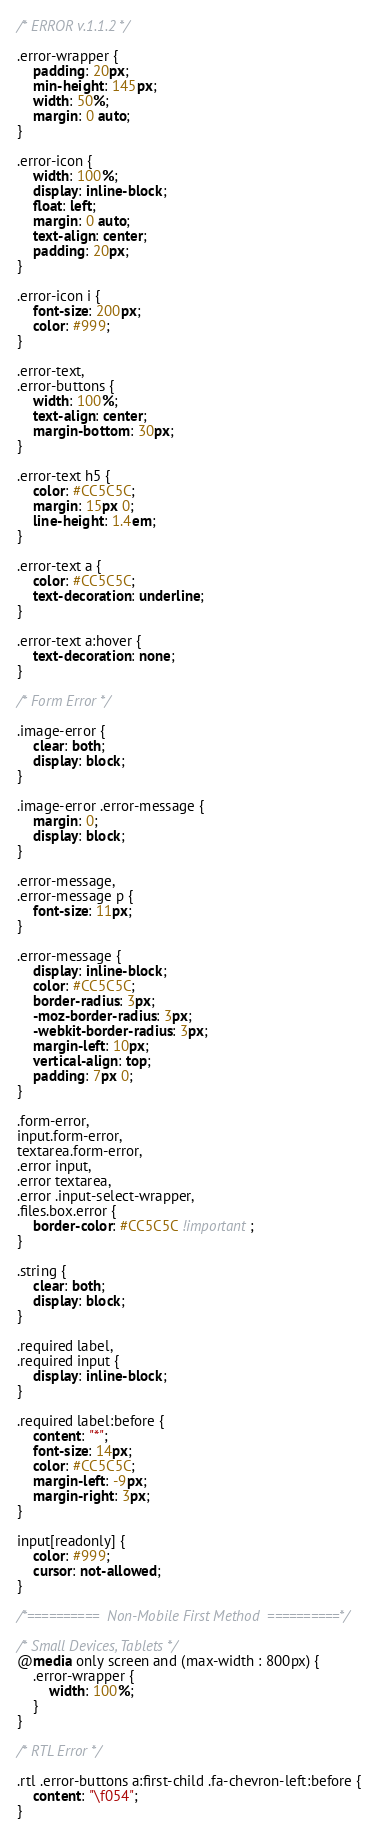Convert code to text. <code><loc_0><loc_0><loc_500><loc_500><_CSS_>/* ERROR v.1.1.2 */

.error-wrapper {
    padding: 20px;
    min-height: 145px;
    width: 50%;
    margin: 0 auto;
}

.error-icon {
    width: 100%;
    display: inline-block;
    float: left;
    margin: 0 auto;
    text-align: center;
    padding: 20px;
}

.error-icon i {
    font-size: 200px;
    color: #999;
}

.error-text,
.error-buttons {
    width: 100%;
    text-align: center;
    margin-bottom: 30px;
}

.error-text h5 {
    color: #CC5C5C;
    margin: 15px 0;
    line-height: 1.4em;
}

.error-text a {
    color: #CC5C5C;
    text-decoration: underline;
}

.error-text a:hover {
    text-decoration: none;
}

/* Form Error */

.image-error {
    clear: both;
    display: block;
}

.image-error .error-message {
    margin: 0;
    display: block;
}

.error-message,
.error-message p {
    font-size: 11px;
}

.error-message {
    display: inline-block;
    color: #CC5C5C;
    border-radius: 3px;
    -moz-border-radius: 3px;
    -webkit-border-radius: 3px;
    margin-left: 10px;
    vertical-align: top;
    padding: 7px 0;
}

.form-error,
input.form-error,
textarea.form-error,
.error input,
.error textarea,
.error .input-select-wrapper,
.files.box.error {
    border-color: #CC5C5C !important;
}

.string {
    clear: both;
    display: block;
}

.required label,
.required input {
    display: inline-block;
}

.required label:before {
    content: "*";
    font-size: 14px;
    color: #CC5C5C;
    margin-left: -9px;
    margin-right: 3px;
}

input[readonly] {
    color: #999;
    cursor: not-allowed;
}

/*==========  Non-Mobile First Method  ==========*/

/* Small Devices, Tablets */
@media only screen and (max-width : 800px) {
    .error-wrapper {
        width: 100%;
    }
}

/* RTL Error */

.rtl .error-buttons a:first-child .fa-chevron-left:before {
    content: "\f054";
}
</code> 